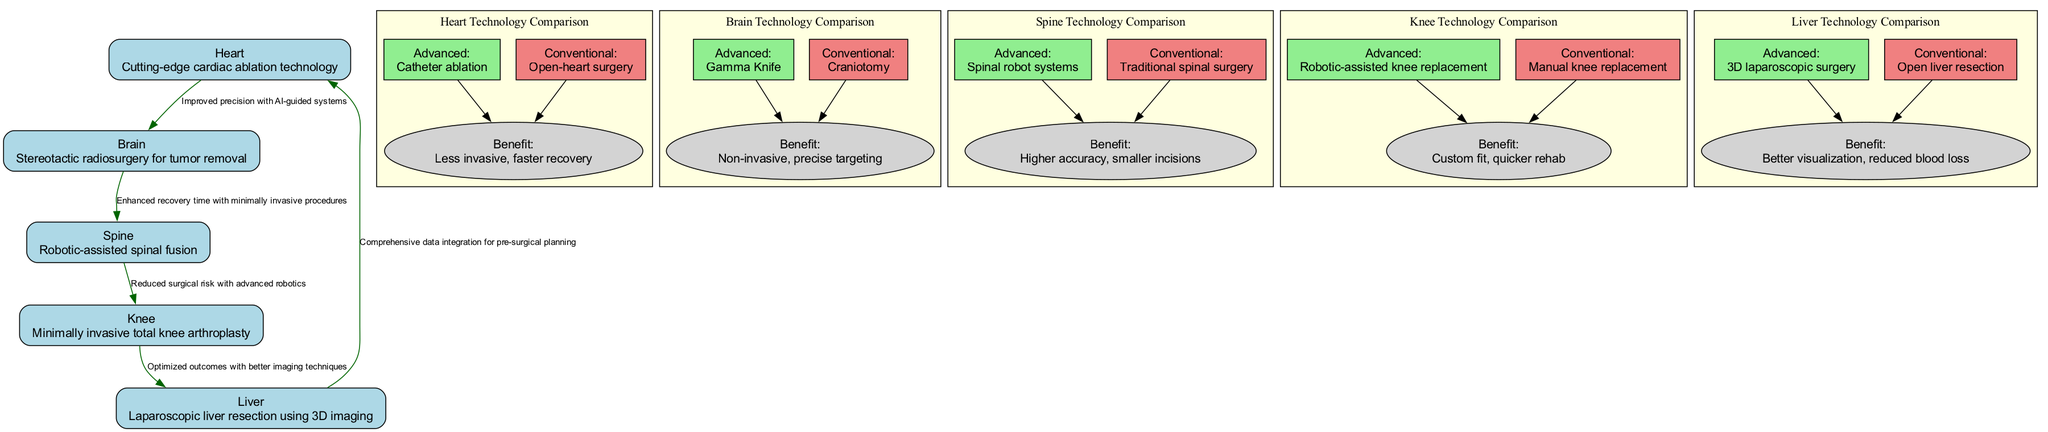What advanced technology is highlighted for the heart? The diagram states "Cutting-edge cardiac ablation technology" as the advanced technology for the heart. This information can be found directly under the 'Heart' node.
Answer: Cutting-edge cardiac ablation technology What surgical technique is associated with the brain? The description under the 'Brain' node indicates "Stereotactic radiosurgery for tumor removal" as the surgical technique used for the brain. This direct description provides the answer.
Answer: Stereotactic radiosurgery for tumor removal How many nodes are present in the diagram? The diagram lists five anatomical parts: heart, brain, spine, knee, and liver. The count of these nodes gives the total number of nodes in the diagram.
Answer: 5 What does the overlay from the brain to the spine indicate? The overlay connecting the brain and spine is labeled "Enhanced recovery time with minimally invasive procedures," which explains the relationship between the two nodes in terms of recovery benefits.
Answer: Enhanced recovery time with minimally invasive procedures What is the benefit of the advanced heart technology compared to conventional methods? The comparison section under the heart node states that the advanced technology, catheter ablation, has the benefit of being "Less invasive, faster recovery" compared to open-heart surgery, which provides the specific benefit.
Answer: Less invasive, faster recovery Which surgical area shows robotic-assisted techniques? The 'Spine' node indicates the use of "Robotic-assisted spinal fusion," directly answering the question regarding the surgical area that employs robotic-assisted techniques.
Answer: Spine What is the relationship between knee and liver overlays? The overlay connecting the knee to the liver indicates "Optimized outcomes with better imaging techniques," demonstrating the perceived improvement in outcomes when using technology between these two areas.
Answer: Optimized outcomes with better imaging techniques What is the advanced technique for liver surgery mentioned? The liver node specifies "Laparoscopic liver resection using 3D imaging" as the advanced surgical technique, directly answering the question about surgery on the liver.
Answer: Laparoscopic liver resection using 3D imaging 